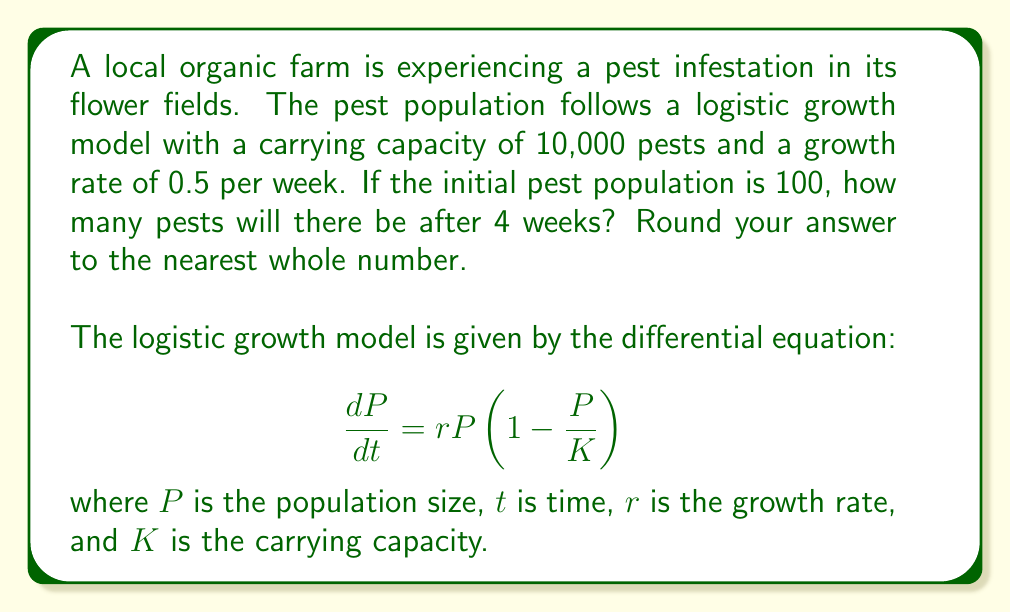Could you help me with this problem? To solve this problem, we need to use the solution to the logistic growth differential equation:

$$P(t) = \frac{K}{1 + (\frac{K}{P_0} - 1)e^{-rt}}$$

Where:
$K = 10,000$ (carrying capacity)
$r = 0.5$ (growth rate per week)
$P_0 = 100$ (initial population)
$t = 4$ (weeks)

Let's substitute these values into the equation:

$$P(4) = \frac{10,000}{1 + (\frac{10,000}{100} - 1)e^{-0.5(4)}}$$

$$= \frac{10,000}{1 + (100 - 1)e^{-2}}$$

$$= \frac{10,000}{1 + 99e^{-2}}$$

Now, let's calculate this step by step:

1. Calculate $e^{-2} \approx 0.1353$
2. Multiply: $99 * 0.1353 \approx 13.3947$
3. Add 1: $1 + 13.3947 = 14.3947$
4. Divide: $10,000 / 14.3947 \approx 694.7205$

Rounding to the nearest whole number, we get 695.
Answer: 695 pests 